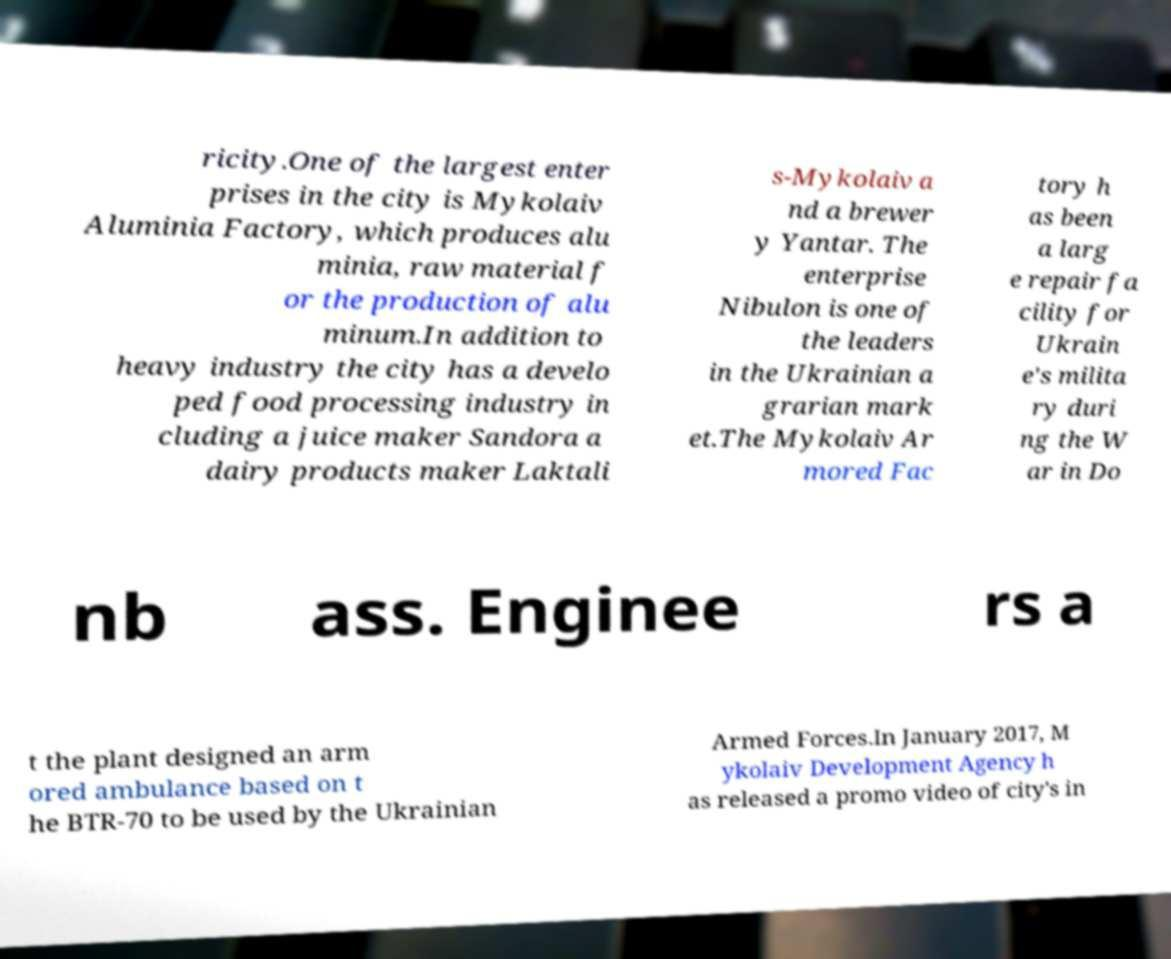Could you extract and type out the text from this image? ricity.One of the largest enter prises in the city is Mykolaiv Aluminia Factory, which produces alu minia, raw material f or the production of alu minum.In addition to heavy industry the city has a develo ped food processing industry in cluding a juice maker Sandora a dairy products maker Laktali s-Mykolaiv a nd a brewer y Yantar. The enterprise Nibulon is one of the leaders in the Ukrainian a grarian mark et.The Mykolaiv Ar mored Fac tory h as been a larg e repair fa cility for Ukrain e's milita ry duri ng the W ar in Do nb ass. Enginee rs a t the plant designed an arm ored ambulance based on t he BTR-70 to be used by the Ukrainian Armed Forces.In January 2017, M ykolaiv Development Agency h as released a promo video of city's in 